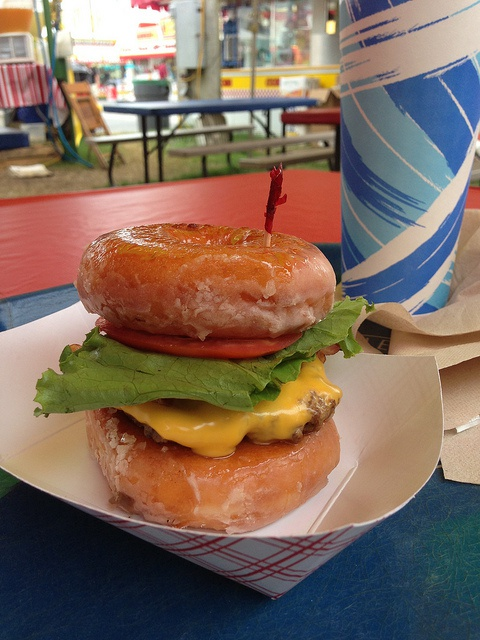Describe the objects in this image and their specific colors. I can see sandwich in white, brown, olive, maroon, and salmon tones, bowl in white, tan, and gray tones, cup in white, gray, blue, and darkgray tones, bench in white, salmon, brown, and lightpink tones, and donut in white, brown, and salmon tones in this image. 